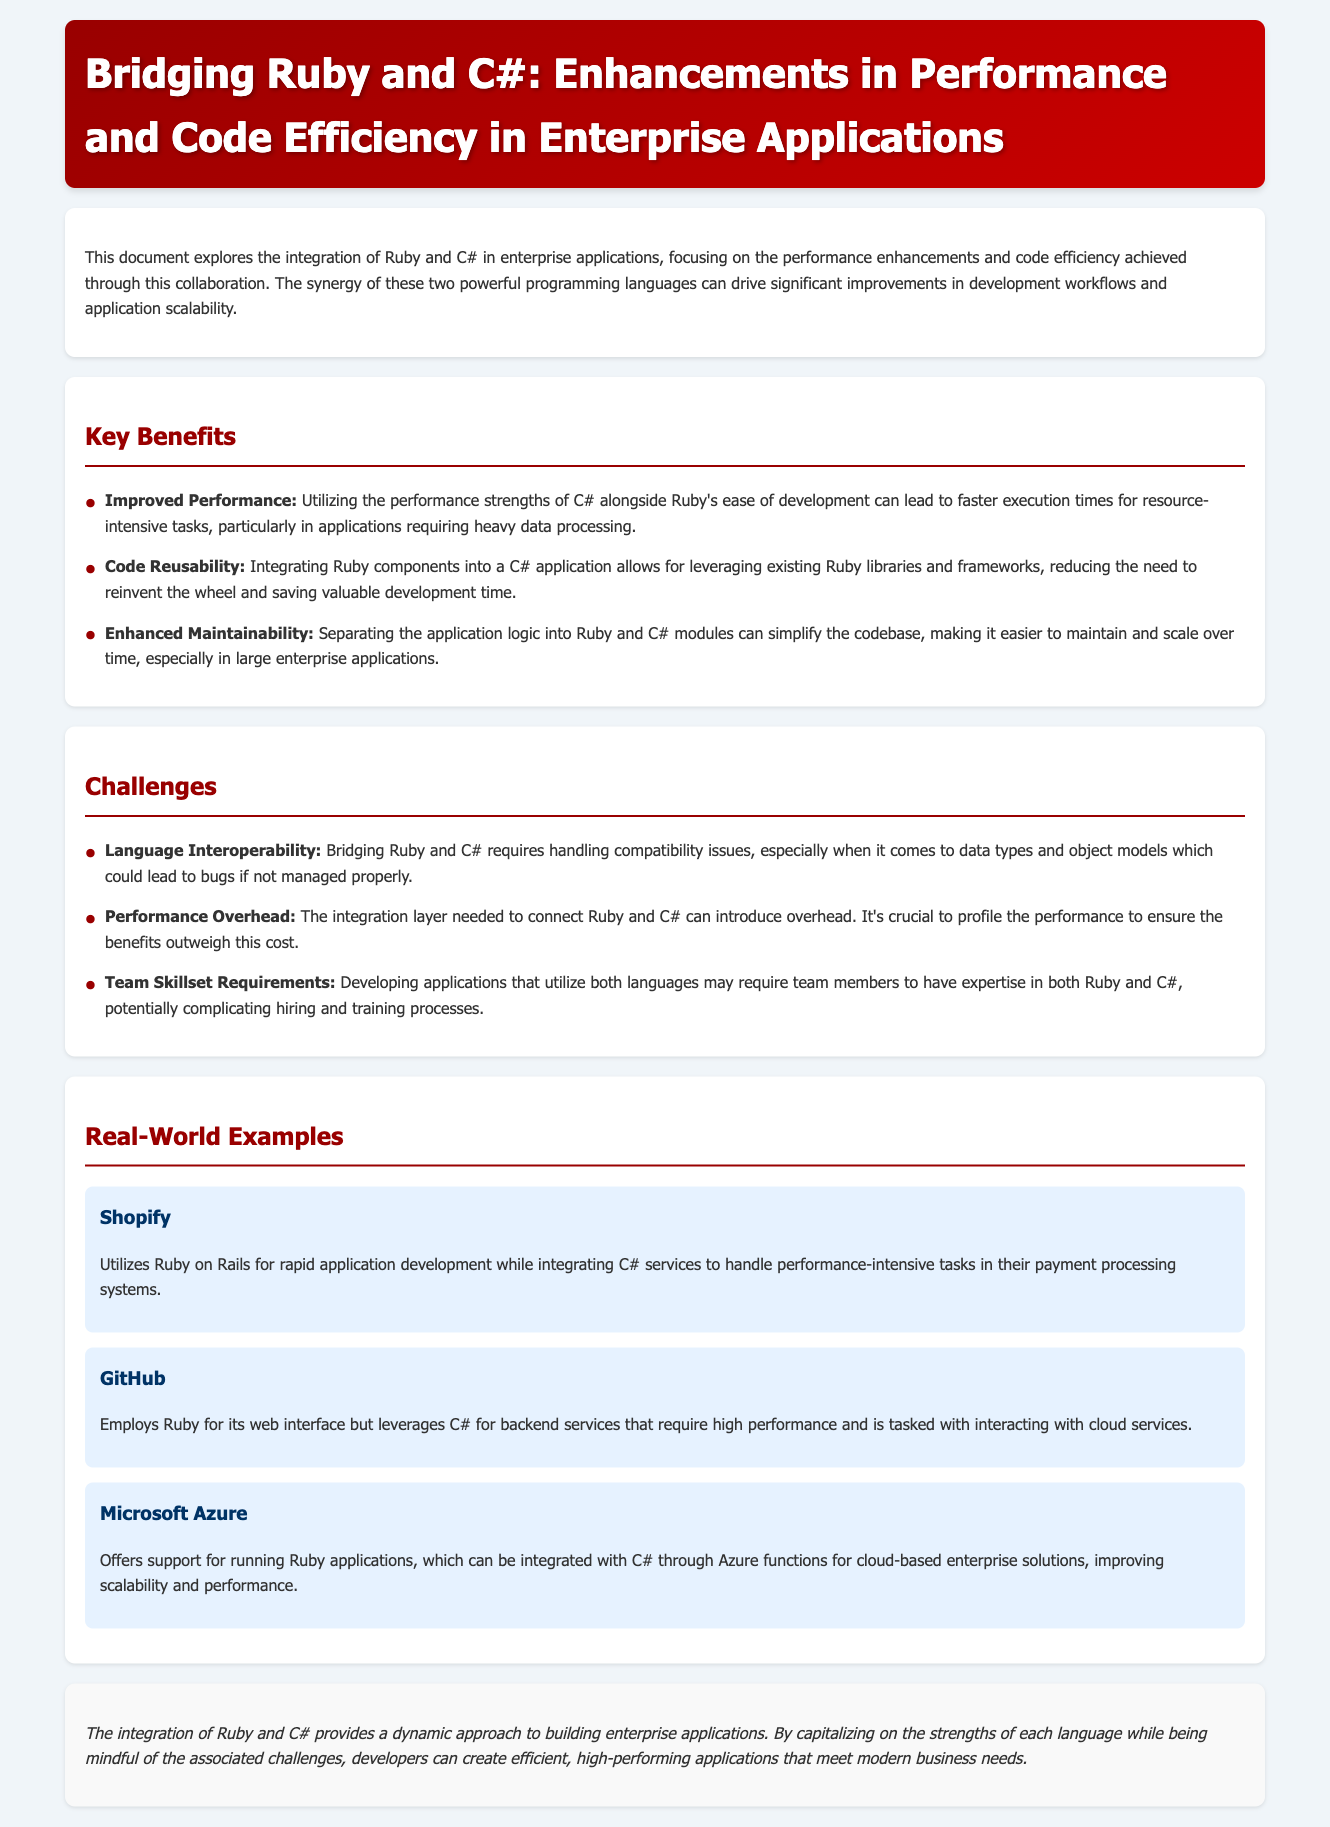what is the title of the document? The title is prominently displayed in the header section of the document.
Answer: Bridging Ruby and C#: Enhancements in Performance and Code Efficiency in Enterprise Applications what is one of the key benefits of integrating Ruby and C#? The document lists several benefits in the "Key Benefits" section.
Answer: Improved Performance name one challenge mentioned in the document. The challenges are outlined in the "Challenges" section.
Answer: Language Interoperability which company is mentioned as utilizing Ruby on Rails? The "Real-World Examples" section provides information about companies and their technologies.
Answer: Shopify how does GitHub utilize Ruby and C#? The document describes the specific roles of Ruby and C# in GitHub's application structure.
Answer: Ruby for its web interface, C# for backend services who is mentioned as offering support for Ruby applications? The "Real-World Examples" section discusses various companies and their services.
Answer: Microsoft Azure what can be identified as a necessary requirement when developing with both Ruby and C#? This information is found in the "Challenges" section regarding team skillset.
Answer: Team Skillset Requirements how does integrating C# affect application execution times? The "Key Benefits" section indicates the impact of C# on performance.
Answer: Faster execution times 